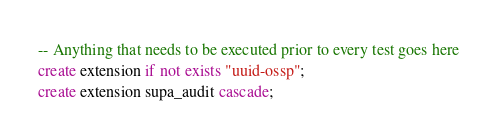<code> <loc_0><loc_0><loc_500><loc_500><_SQL_>-- Anything that needs to be executed prior to every test goes here
create extension if not exists "uuid-ossp";
create extension supa_audit cascade;
</code> 